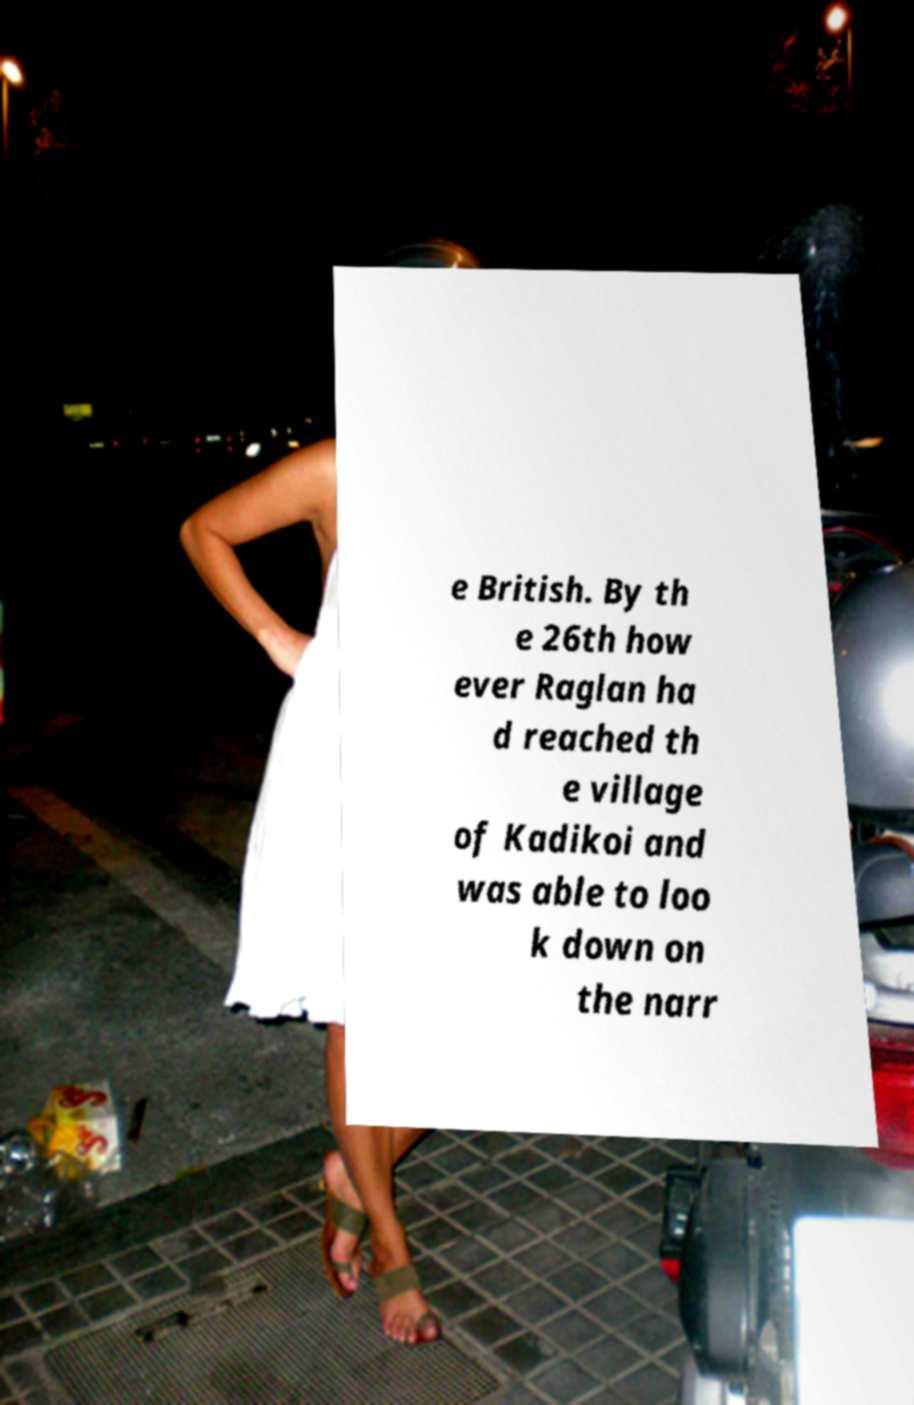There's text embedded in this image that I need extracted. Can you transcribe it verbatim? e British. By th e 26th how ever Raglan ha d reached th e village of Kadikoi and was able to loo k down on the narr 